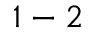<formula> <loc_0><loc_0><loc_500><loc_500>1 - 2</formula> 